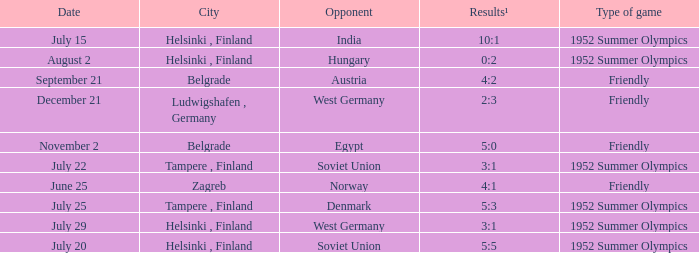With the Type is game of friendly and the City Belgrade and November 2 as the Date what were the Results¹? 5:0. 